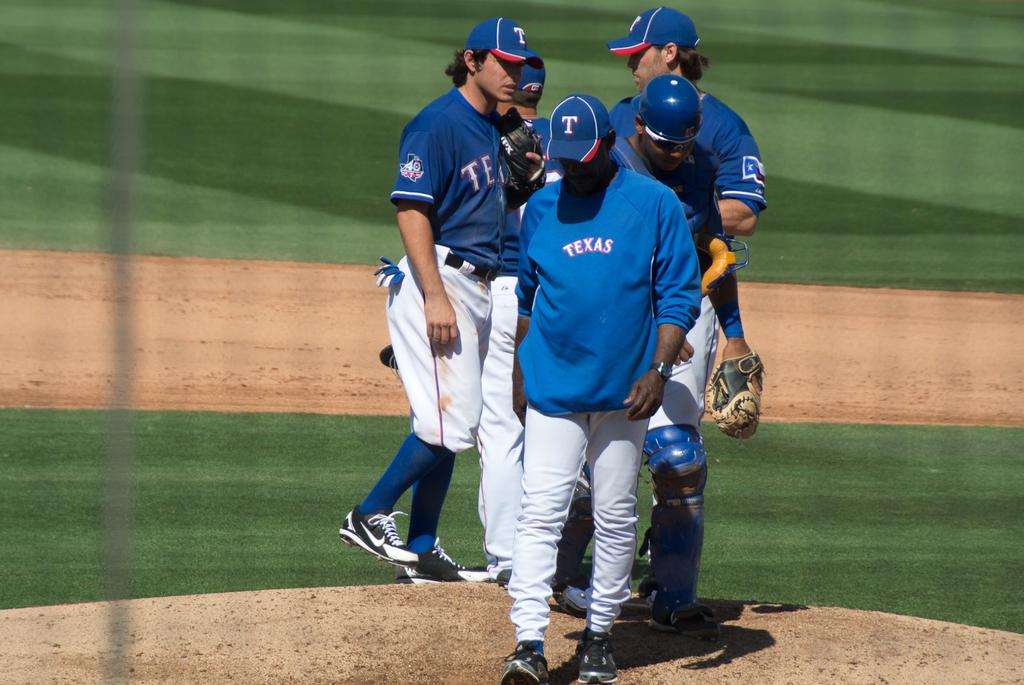What can be seen in the image? There are players in the image. Where are the players located? The players are standing on a ground. What type of door can be seen in the image? There is no door present in the image; it features players standing on a ground. How many necks can be counted on the players in the image? The number of necks cannot be determined from the image, as it only shows the players' bodies from the waist up. 